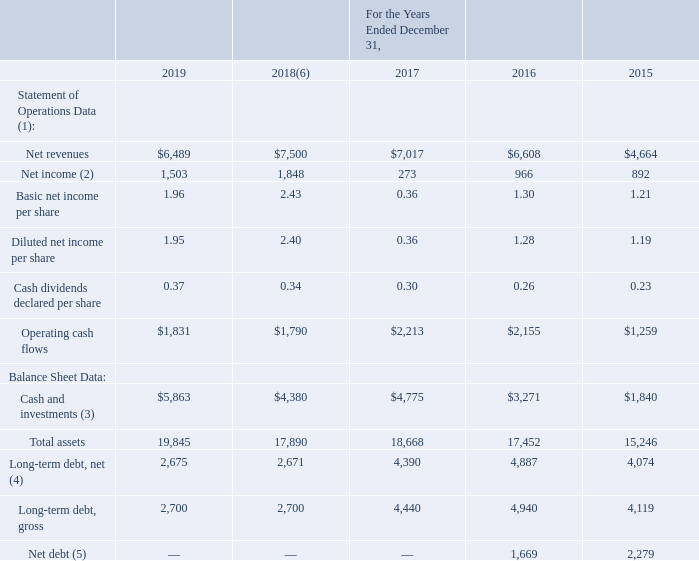Item 6. SELECTED FINANCIAL DATA
The following table summarizes certain selected consolidated financial data, which should be read in conjunction with our consolidated financial statements and notes thereto in Item 8 and with “Management’s Discussion and Analysis of Financial Condition and Results of Operations” included under Item 7 in this Annual Report on Form 10-K. The selected consolidated financial data presented below at and for each of the years in the five-year period ended December 31, 2019, is derived from our consolidated financial statements and include the operations of King commencing on February 23, 2016. All amounts set forth in the following tables are in millions, except per share data.
(1) On January 1, 2018, we adopted a new revenue accounting standard utilizing the modified retrospective method of transition. As a result, periods prior to January 1, 2018 have not been restated to reflect the new accounting standard and continue to be reported under the accounting standards that were in effect for those periods.
(2) Net income for 2019, 2018, and 2017 includes the impact of significant discrete tax-related impacts, including incremental income tax expense and benefits in 2017 and 2018 due to the application of the U.S. Tax Reform Act. See further discussion in Note 19 of the notes to the consolidated financial statements included in Item 8 of this Annual Report on Form 10-K.
(3) Cash and investments consists of cash and cash equivalents along with short-term and long-term investments. We had total investments of $69 million, $155 million, $62 million, $26 million, and $17 million, as of December 31, 2019, December 31, 2018, December 31, 2017, December 31, 2016, and December 31, 2015, respectively. Cash and investments as of December 31, 2015, excludes $3,561 million of cash placed in escrow for the acquisition of King.
(4) For discussion on our debt obligations, see Note 13 of the notes to the consolidated financial statements included in Item 8 of this Annual Report on Form 10-K.
(5) Net debt is defined as long-term debt, gross less cash and investments
(6) During the three months ended March 31, 2019, we identified an amount which should have been recorded in the three months and year ended December 31, 2018 to reduce income tax expense by $35 million. Our selected financial data for the year ended December 31, 2018, as presented above, has been revised to reflect the correction. See further discussion in Note 2 of the notes to the consolidated financial statements included in Item 8 of this Annual Report on Form 10-K.
What did net income for 2019, 2018 and 2017 include? The impact of significant discrete tax-related impacts, including incremental income tax expense and benefits in 2017 and 2018 due to the application of the u.s. tax reform act. What was net revenue in 2019?
Answer scale should be: million. $6,489. What was net income in 2019?
Answer scale should be: million. 1,503. What is the change in operating cash flows between 2018 and 2019?
Answer scale should be: million. ($1,831-$1,790)
Answer: 41. What is the change in total assets between 2015 and 2016?
Answer scale should be: million. (17,452-15,246)
Answer: 2206. What is the percentage change in Cash and Investments between 2016 and 2017?
Answer scale should be: percent. ($4,775-$3,271)/$3,271
Answer: 45.98. 